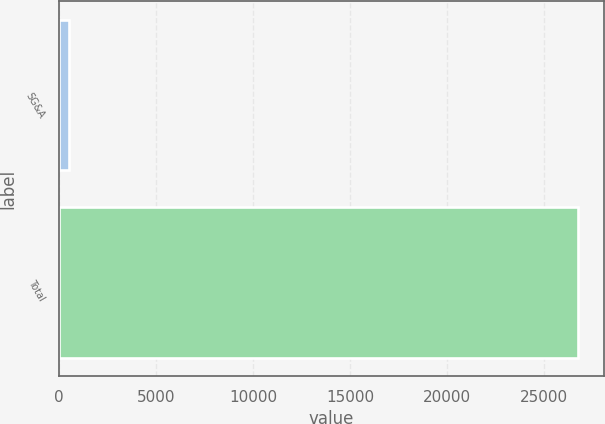<chart> <loc_0><loc_0><loc_500><loc_500><bar_chart><fcel>SG&A<fcel>Total<nl><fcel>523<fcel>26740<nl></chart> 